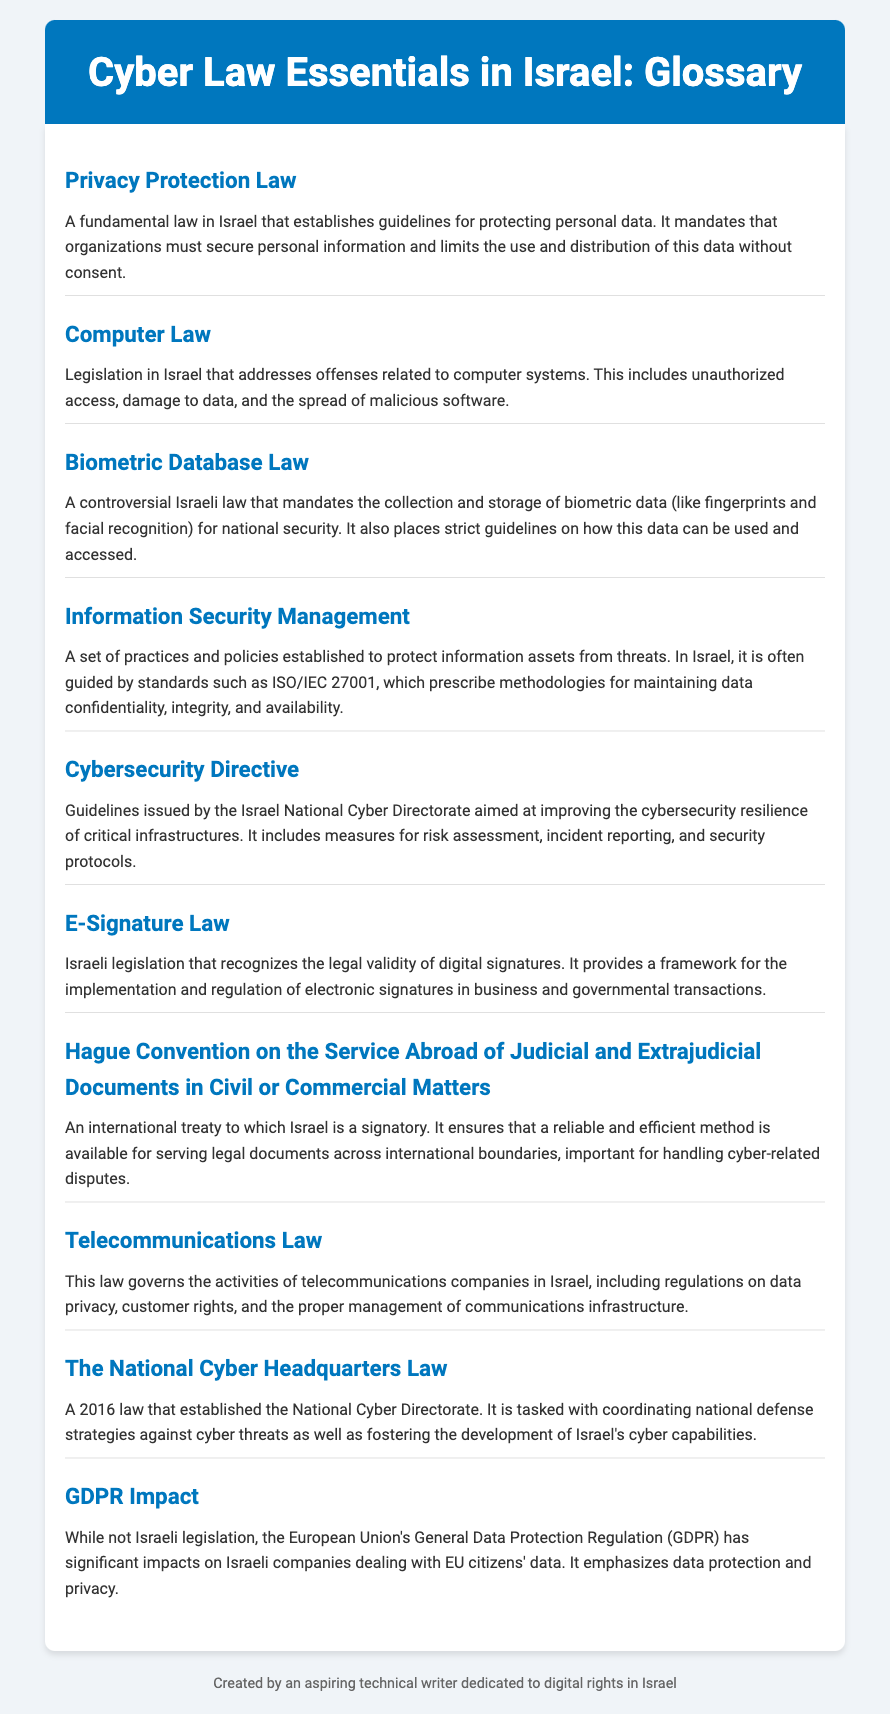What is the title of the document? The title of the document is the main heading that introduces the subject, which is "Cyber Law Essentials in Israel: Glossary."
Answer: Cyber Law Essentials in Israel: Glossary What law mandates the collection of biometric data in Israel? The specific law that mandates the collection and storage of biometric data is mentioned in the document as the "Biometric Database Law."
Answer: Biometric Database Law Which standard is often referenced for information security management in Israel? The document outlines that ISO/IEC 27001 is the standard often guiding information security management in Israel.
Answer: ISO/IEC 27001 What does the Cybersecurity Directive aim to improve? The Cybersecurity Directive is aimed at improving the cybersecurity resilience of critical infrastructures in Israel.
Answer: Cybersecurity resilience What is the legal recognition provided by the E-Signature Law? The E-Signature Law acknowledges the legal validity of a specific kind of signing method, which is digital signatures.
Answer: Digital signatures Which law governs the telecommunications companies in Israel? The law that governs telecommunications companies is referred to in the document as the "Telecommunications Law."
Answer: Telecommunications Law What international treaty is Israel a signatory to, related to legal documents? The treaty concerning the serving of legal documents internationally is known as the "Hague Convention on the Service Abroad of Judicial and Extrajudicial Documents in Civil or Commercial Matters."
Answer: Hague Convention What year was the National Cyber Headquarters Law established? The document provides the year when the National Cyber Headquarters Law was established, which is 2016.
Answer: 2016 Which regulation has significant impacts on Israeli companies dealing with EU citizens' data? The document indicates that the European Union's General Data Protection Regulation (GDPR) significantly impacts Israeli companies.
Answer: GDPR 